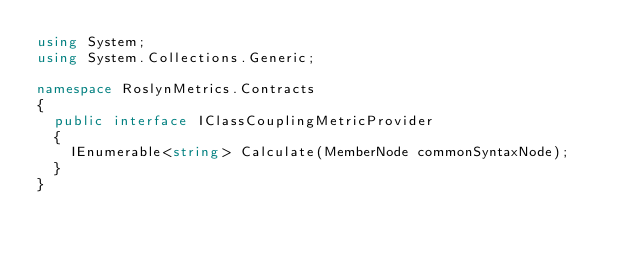<code> <loc_0><loc_0><loc_500><loc_500><_C#_>using System;
using System.Collections.Generic;

namespace RoslynMetrics.Contracts
{
	public interface IClassCouplingMetricProvider
	{
		IEnumerable<string> Calculate(MemberNode commonSyntaxNode);
	}
}</code> 